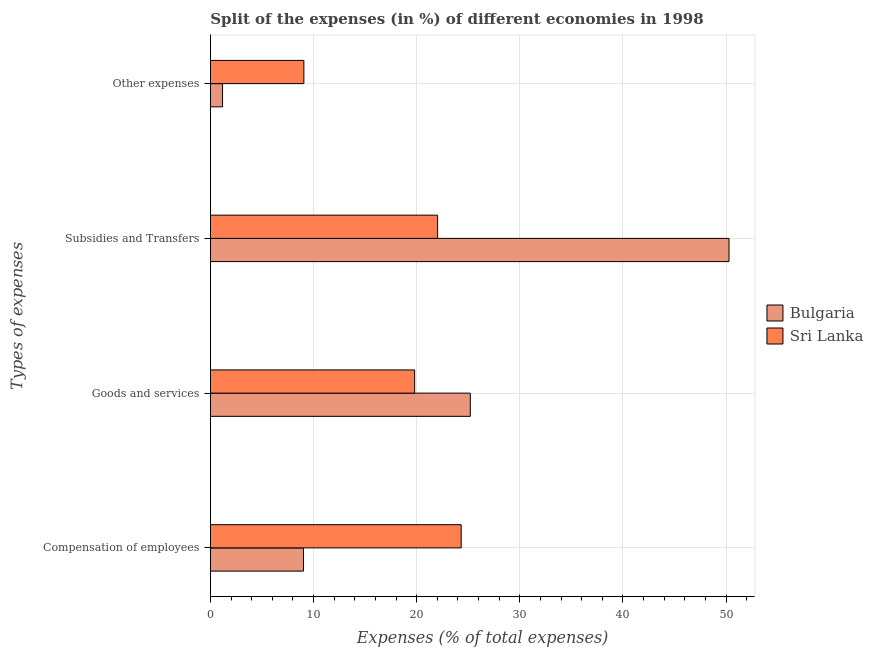How many bars are there on the 1st tick from the bottom?
Give a very brief answer. 2. What is the label of the 4th group of bars from the top?
Provide a succinct answer. Compensation of employees. What is the percentage of amount spent on goods and services in Bulgaria?
Ensure brevity in your answer.  25.2. Across all countries, what is the maximum percentage of amount spent on compensation of employees?
Your answer should be very brief. 24.32. Across all countries, what is the minimum percentage of amount spent on compensation of employees?
Provide a succinct answer. 9.03. In which country was the percentage of amount spent on compensation of employees maximum?
Offer a very short reply. Sri Lanka. In which country was the percentage of amount spent on compensation of employees minimum?
Your response must be concise. Bulgaria. What is the total percentage of amount spent on other expenses in the graph?
Provide a short and direct response. 10.24. What is the difference between the percentage of amount spent on goods and services in Sri Lanka and that in Bulgaria?
Offer a very short reply. -5.4. What is the difference between the percentage of amount spent on other expenses in Bulgaria and the percentage of amount spent on compensation of employees in Sri Lanka?
Your answer should be compact. -23.14. What is the average percentage of amount spent on goods and services per country?
Make the answer very short. 22.51. What is the difference between the percentage of amount spent on compensation of employees and percentage of amount spent on subsidies in Sri Lanka?
Ensure brevity in your answer.  2.29. What is the ratio of the percentage of amount spent on subsidies in Sri Lanka to that in Bulgaria?
Make the answer very short. 0.44. Is the percentage of amount spent on compensation of employees in Sri Lanka less than that in Bulgaria?
Ensure brevity in your answer.  No. Is the difference between the percentage of amount spent on goods and services in Sri Lanka and Bulgaria greater than the difference between the percentage of amount spent on other expenses in Sri Lanka and Bulgaria?
Provide a short and direct response. No. What is the difference between the highest and the second highest percentage of amount spent on subsidies?
Offer a very short reply. 28.26. What is the difference between the highest and the lowest percentage of amount spent on subsidies?
Your answer should be compact. 28.26. What does the 1st bar from the top in Other expenses represents?
Offer a very short reply. Sri Lanka. What does the 1st bar from the bottom in Goods and services represents?
Your answer should be compact. Bulgaria. Is it the case that in every country, the sum of the percentage of amount spent on compensation of employees and percentage of amount spent on goods and services is greater than the percentage of amount spent on subsidies?
Provide a succinct answer. No. Are all the bars in the graph horizontal?
Offer a terse response. Yes. Where does the legend appear in the graph?
Provide a succinct answer. Center right. What is the title of the graph?
Offer a terse response. Split of the expenses (in %) of different economies in 1998. What is the label or title of the X-axis?
Give a very brief answer. Expenses (% of total expenses). What is the label or title of the Y-axis?
Give a very brief answer. Types of expenses. What is the Expenses (% of total expenses) in Bulgaria in Compensation of employees?
Your answer should be compact. 9.03. What is the Expenses (% of total expenses) in Sri Lanka in Compensation of employees?
Offer a very short reply. 24.32. What is the Expenses (% of total expenses) in Bulgaria in Goods and services?
Your answer should be compact. 25.2. What is the Expenses (% of total expenses) in Sri Lanka in Goods and services?
Make the answer very short. 19.81. What is the Expenses (% of total expenses) of Bulgaria in Subsidies and Transfers?
Make the answer very short. 50.29. What is the Expenses (% of total expenses) in Sri Lanka in Subsidies and Transfers?
Give a very brief answer. 22.03. What is the Expenses (% of total expenses) in Bulgaria in Other expenses?
Offer a very short reply. 1.18. What is the Expenses (% of total expenses) in Sri Lanka in Other expenses?
Keep it short and to the point. 9.07. Across all Types of expenses, what is the maximum Expenses (% of total expenses) of Bulgaria?
Offer a very short reply. 50.29. Across all Types of expenses, what is the maximum Expenses (% of total expenses) in Sri Lanka?
Offer a very short reply. 24.32. Across all Types of expenses, what is the minimum Expenses (% of total expenses) of Bulgaria?
Your answer should be very brief. 1.18. Across all Types of expenses, what is the minimum Expenses (% of total expenses) of Sri Lanka?
Provide a succinct answer. 9.07. What is the total Expenses (% of total expenses) in Bulgaria in the graph?
Give a very brief answer. 85.7. What is the total Expenses (% of total expenses) of Sri Lanka in the graph?
Ensure brevity in your answer.  75.22. What is the difference between the Expenses (% of total expenses) in Bulgaria in Compensation of employees and that in Goods and services?
Keep it short and to the point. -16.17. What is the difference between the Expenses (% of total expenses) in Sri Lanka in Compensation of employees and that in Goods and services?
Offer a terse response. 4.51. What is the difference between the Expenses (% of total expenses) in Bulgaria in Compensation of employees and that in Subsidies and Transfers?
Ensure brevity in your answer.  -41.26. What is the difference between the Expenses (% of total expenses) in Sri Lanka in Compensation of employees and that in Subsidies and Transfers?
Give a very brief answer. 2.29. What is the difference between the Expenses (% of total expenses) of Bulgaria in Compensation of employees and that in Other expenses?
Make the answer very short. 7.85. What is the difference between the Expenses (% of total expenses) of Sri Lanka in Compensation of employees and that in Other expenses?
Offer a terse response. 15.25. What is the difference between the Expenses (% of total expenses) of Bulgaria in Goods and services and that in Subsidies and Transfers?
Provide a short and direct response. -25.08. What is the difference between the Expenses (% of total expenses) in Sri Lanka in Goods and services and that in Subsidies and Transfers?
Your answer should be compact. -2.22. What is the difference between the Expenses (% of total expenses) in Bulgaria in Goods and services and that in Other expenses?
Offer a terse response. 24.02. What is the difference between the Expenses (% of total expenses) of Sri Lanka in Goods and services and that in Other expenses?
Provide a short and direct response. 10.74. What is the difference between the Expenses (% of total expenses) of Bulgaria in Subsidies and Transfers and that in Other expenses?
Make the answer very short. 49.11. What is the difference between the Expenses (% of total expenses) in Sri Lanka in Subsidies and Transfers and that in Other expenses?
Provide a succinct answer. 12.97. What is the difference between the Expenses (% of total expenses) of Bulgaria in Compensation of employees and the Expenses (% of total expenses) of Sri Lanka in Goods and services?
Ensure brevity in your answer.  -10.78. What is the difference between the Expenses (% of total expenses) of Bulgaria in Compensation of employees and the Expenses (% of total expenses) of Sri Lanka in Subsidies and Transfers?
Your answer should be very brief. -13. What is the difference between the Expenses (% of total expenses) of Bulgaria in Compensation of employees and the Expenses (% of total expenses) of Sri Lanka in Other expenses?
Your answer should be compact. -0.04. What is the difference between the Expenses (% of total expenses) of Bulgaria in Goods and services and the Expenses (% of total expenses) of Sri Lanka in Subsidies and Transfers?
Provide a short and direct response. 3.17. What is the difference between the Expenses (% of total expenses) in Bulgaria in Goods and services and the Expenses (% of total expenses) in Sri Lanka in Other expenses?
Make the answer very short. 16.14. What is the difference between the Expenses (% of total expenses) of Bulgaria in Subsidies and Transfers and the Expenses (% of total expenses) of Sri Lanka in Other expenses?
Ensure brevity in your answer.  41.22. What is the average Expenses (% of total expenses) in Bulgaria per Types of expenses?
Ensure brevity in your answer.  21.43. What is the average Expenses (% of total expenses) of Sri Lanka per Types of expenses?
Offer a very short reply. 18.81. What is the difference between the Expenses (% of total expenses) of Bulgaria and Expenses (% of total expenses) of Sri Lanka in Compensation of employees?
Your response must be concise. -15.29. What is the difference between the Expenses (% of total expenses) of Bulgaria and Expenses (% of total expenses) of Sri Lanka in Goods and services?
Your response must be concise. 5.4. What is the difference between the Expenses (% of total expenses) in Bulgaria and Expenses (% of total expenses) in Sri Lanka in Subsidies and Transfers?
Provide a short and direct response. 28.26. What is the difference between the Expenses (% of total expenses) in Bulgaria and Expenses (% of total expenses) in Sri Lanka in Other expenses?
Offer a terse response. -7.89. What is the ratio of the Expenses (% of total expenses) in Bulgaria in Compensation of employees to that in Goods and services?
Provide a succinct answer. 0.36. What is the ratio of the Expenses (% of total expenses) of Sri Lanka in Compensation of employees to that in Goods and services?
Offer a very short reply. 1.23. What is the ratio of the Expenses (% of total expenses) of Bulgaria in Compensation of employees to that in Subsidies and Transfers?
Offer a terse response. 0.18. What is the ratio of the Expenses (% of total expenses) of Sri Lanka in Compensation of employees to that in Subsidies and Transfers?
Your answer should be compact. 1.1. What is the ratio of the Expenses (% of total expenses) of Bulgaria in Compensation of employees to that in Other expenses?
Give a very brief answer. 7.66. What is the ratio of the Expenses (% of total expenses) of Sri Lanka in Compensation of employees to that in Other expenses?
Your answer should be compact. 2.68. What is the ratio of the Expenses (% of total expenses) in Bulgaria in Goods and services to that in Subsidies and Transfers?
Offer a terse response. 0.5. What is the ratio of the Expenses (% of total expenses) of Sri Lanka in Goods and services to that in Subsidies and Transfers?
Provide a succinct answer. 0.9. What is the ratio of the Expenses (% of total expenses) in Bulgaria in Goods and services to that in Other expenses?
Provide a succinct answer. 21.37. What is the ratio of the Expenses (% of total expenses) in Sri Lanka in Goods and services to that in Other expenses?
Provide a short and direct response. 2.18. What is the ratio of the Expenses (% of total expenses) of Bulgaria in Subsidies and Transfers to that in Other expenses?
Ensure brevity in your answer.  42.64. What is the ratio of the Expenses (% of total expenses) in Sri Lanka in Subsidies and Transfers to that in Other expenses?
Ensure brevity in your answer.  2.43. What is the difference between the highest and the second highest Expenses (% of total expenses) in Bulgaria?
Provide a succinct answer. 25.08. What is the difference between the highest and the second highest Expenses (% of total expenses) in Sri Lanka?
Offer a very short reply. 2.29. What is the difference between the highest and the lowest Expenses (% of total expenses) in Bulgaria?
Your answer should be very brief. 49.11. What is the difference between the highest and the lowest Expenses (% of total expenses) in Sri Lanka?
Your answer should be very brief. 15.25. 